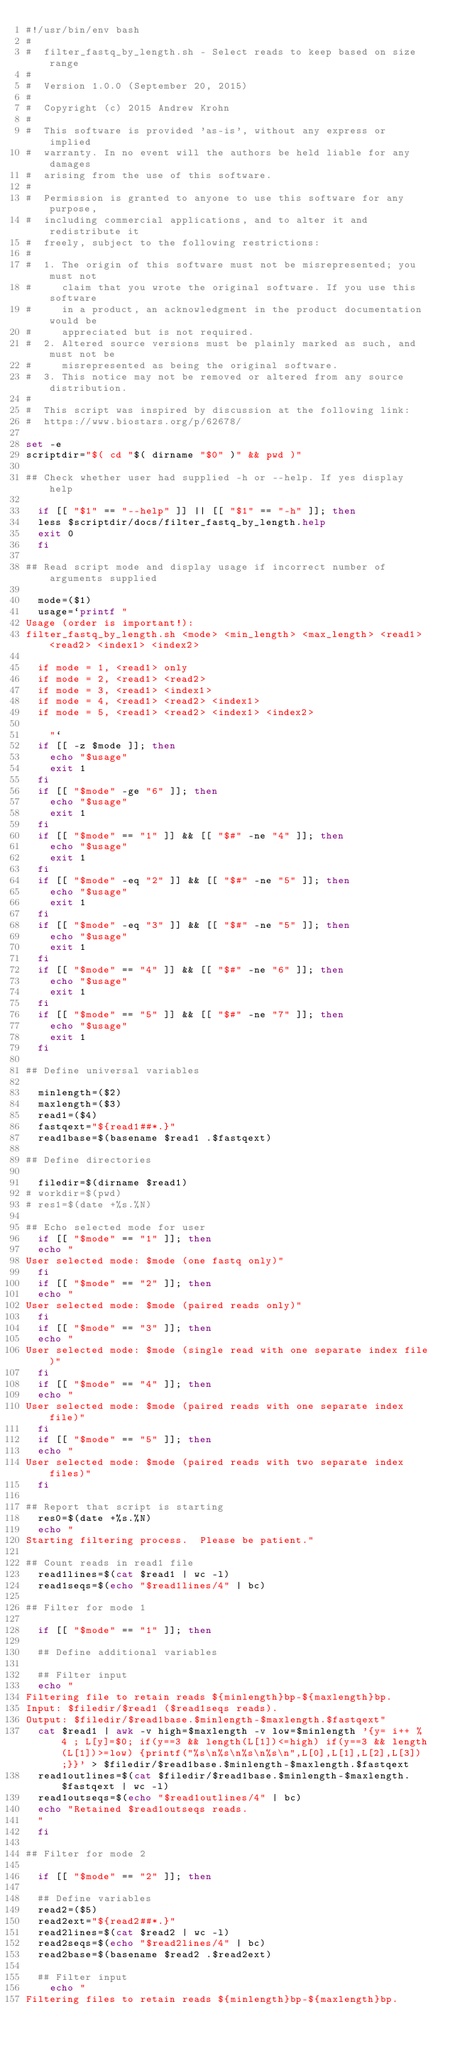<code> <loc_0><loc_0><loc_500><loc_500><_Bash_>#!/usr/bin/env bash
#
#  filter_fastq_by_length.sh - Select reads to keep based on size range
#
#  Version 1.0.0 (September 20, 2015)
#
#  Copyright (c) 2015 Andrew Krohn
#
#  This software is provided 'as-is', without any express or implied
#  warranty. In no event will the authors be held liable for any damages
#  arising from the use of this software.
#
#  Permission is granted to anyone to use this software for any purpose,
#  including commercial applications, and to alter it and redistribute it
#  freely, subject to the following restrictions:
#
#  1. The origin of this software must not be misrepresented; you must not
#     claim that you wrote the original software. If you use this software
#     in a product, an acknowledgment in the product documentation would be
#     appreciated but is not required.
#  2. Altered source versions must be plainly marked as such, and must not be
#     misrepresented as being the original software.
#  3. This notice may not be removed or altered from any source distribution.
#
#  This script was inspired by discussion at the following link:
#  https://www.biostars.org/p/62678/

set -e
scriptdir="$( cd "$( dirname "$0" )" && pwd )"

## Check whether user had supplied -h or --help. If yes display help 

	if [[ "$1" == "--help" ]] || [[ "$1" == "-h" ]]; then
	less $scriptdir/docs/filter_fastq_by_length.help
	exit 0
	fi 

## Read script mode and display usage if incorrect number of arguments supplied

	mode=($1)
	usage=`printf "
Usage (order is important!):
filter_fastq_by_length.sh <mode> <min_length> <max_length> <read1> <read2> <index1> <index2>

	if mode = 1, <read1> only
	if mode = 2, <read1> <read2>
	if mode = 3, <read1> <index1>
	if mode = 4, <read1> <read2> <index1>
	if mode = 5, <read1> <read2> <index1> <index2>
   
		"`
	if [[ -z $mode ]]; then
		echo "$usage"
		exit 1
	fi
	if [[ "$mode" -ge "6" ]]; then
		echo "$usage"
		exit 1
	fi
	if [[ "$mode" == "1" ]] && [[ "$#" -ne "4" ]]; then
		echo "$usage"
		exit 1
	fi
	if [[ "$mode" -eq "2" ]] && [[ "$#" -ne "5" ]]; then
		echo "$usage"
		exit 1
	fi
	if [[ "$mode" -eq "3" ]] && [[ "$#" -ne "5" ]]; then
		echo "$usage"
		exit 1
	fi
	if [[ "$mode" == "4" ]] && [[ "$#" -ne "6" ]]; then
		echo "$usage"
		exit 1
	fi
	if [[ "$mode" == "5" ]] && [[ "$#" -ne "7" ]]; then
		echo "$usage"
		exit 1
	fi

## Define universal variables

	minlength=($2)
	maxlength=($3)
	read1=($4)
	fastqext="${read1##*.}"
	read1base=$(basename $read1 .$fastqext)

## Define directories
  
	filedir=$(dirname $read1)
#	workdir=$(pwd)
#	res1=$(date +%s.%N)

## Echo selected mode for user
	if [[ "$mode" == "1" ]]; then
	echo "
User selected mode: $mode (one fastq only)"
	fi
	if [[ "$mode" == "2" ]]; then
	echo "
User selected mode: $mode (paired reads only)"
	fi
	if [[ "$mode" == "3" ]]; then
	echo "
User selected mode: $mode (single read with one separate index file)"
	fi
	if [[ "$mode" == "4" ]]; then
	echo "
User selected mode: $mode (paired reads with one separate index file)"
	fi
	if [[ "$mode" == "5" ]]; then
	echo "
User selected mode: $mode (paired reads with two separate index files)"
	fi

## Report that script is starting
	res0=$(date +%s.%N)
	echo "
Starting filtering process.  Please be patient."

## Count reads in read1 file
	read1lines=$(cat $read1 | wc -l)
	read1seqs=$(echo "$read1lines/4" | bc)

## Filter for mode 1

	if [[ "$mode" == "1" ]]; then

	## Define additional variables

	## Filter input
	echo "
Filtering file to retain reads ${minlength}bp-${maxlength}bp.
Input: $filedir/$read1 ($read1seqs reads).
Output: $filedir/$read1base.$minlength-$maxlength.$fastqext"
	cat $read1 | awk -v high=$maxlength -v low=$minlength '{y= i++ % 4 ; L[y]=$0; if(y==3 && length(L[1])<=high) if(y==3 && length(L[1])>=low) {printf("%s\n%s\n%s\n%s\n",L[0],L[1],L[2],L[3]);}}' > $filedir/$read1base.$minlength-$maxlength.$fastqext
	read1outlines=$(cat $filedir/$read1base.$minlength-$maxlength.$fastqext | wc -l)
	read1outseqs=$(echo "$read1outlines/4" | bc)
	echo "Retained $read1outseqs reads.
	"
	fi

## Filter for mode 2

	if [[ "$mode" == "2" ]]; then

	## Define variables
	read2=($5)
	read2ext="${read2##*.}"
	read2lines=$(cat $read2 | wc -l)
	read2seqs=$(echo "$read2lines/4" | bc)
	read2base=$(basename $read2 .$read2ext)

	## Filter input
		echo "
Filtering files to retain reads ${minlength}bp-${maxlength}bp.</code> 